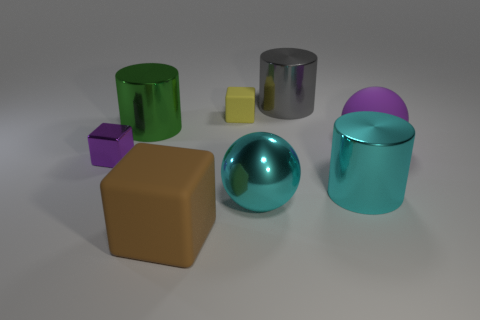The large thing that is on the right side of the large shiny ball and left of the big cyan metallic cylinder is what color?
Make the answer very short. Gray. What color is the block on the right side of the rubber object that is in front of the cylinder in front of the purple metallic thing?
Offer a very short reply. Yellow. What is the color of the rubber cube that is the same size as the metal block?
Your answer should be very brief. Yellow. There is a big metal thing behind the tiny block that is right of the purple thing left of the green metallic cylinder; what shape is it?
Give a very brief answer. Cylinder. There is a small object that is the same color as the matte ball; what is its shape?
Your response must be concise. Cube. What number of objects are tiny objects or rubber things behind the cyan ball?
Offer a very short reply. 3. Is the size of the purple object that is left of the brown rubber object the same as the tiny yellow matte cube?
Offer a very short reply. Yes. There is a small thing that is behind the big green cylinder; what material is it?
Offer a very short reply. Rubber. Are there the same number of cubes that are behind the cyan metallic sphere and tiny cubes on the left side of the yellow thing?
Offer a terse response. No. There is another tiny thing that is the same shape as the tiny metallic object; what color is it?
Your response must be concise. Yellow. 